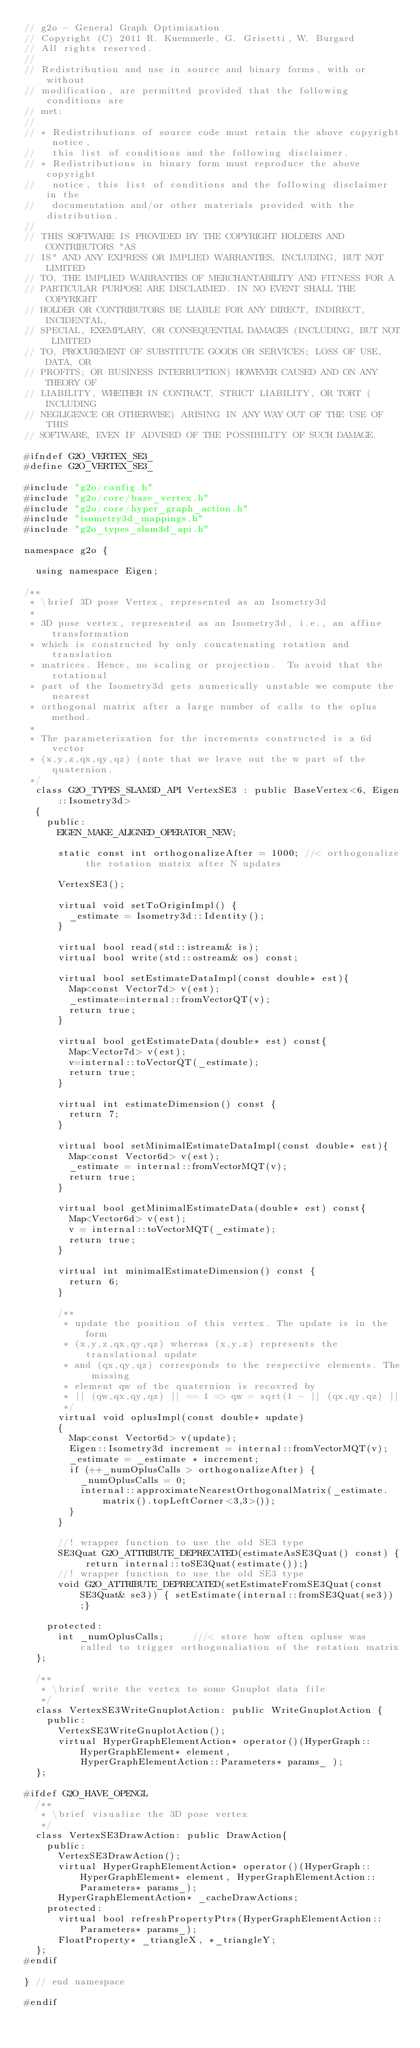Convert code to text. <code><loc_0><loc_0><loc_500><loc_500><_C_>// g2o - General Graph Optimization
// Copyright (C) 2011 R. Kuemmerle, G. Grisetti, W. Burgard
// All rights reserved.
//
// Redistribution and use in source and binary forms, with or without
// modification, are permitted provided that the following conditions are
// met:
//
// * Redistributions of source code must retain the above copyright notice,
//   this list of conditions and the following disclaimer.
// * Redistributions in binary form must reproduce the above copyright
//   notice, this list of conditions and the following disclaimer in the
//   documentation and/or other materials provided with the distribution.
//
// THIS SOFTWARE IS PROVIDED BY THE COPYRIGHT HOLDERS AND CONTRIBUTORS "AS
// IS" AND ANY EXPRESS OR IMPLIED WARRANTIES, INCLUDING, BUT NOT LIMITED
// TO, THE IMPLIED WARRANTIES OF MERCHANTABILITY AND FITNESS FOR A
// PARTICULAR PURPOSE ARE DISCLAIMED. IN NO EVENT SHALL THE COPYRIGHT
// HOLDER OR CONTRIBUTORS BE LIABLE FOR ANY DIRECT, INDIRECT, INCIDENTAL,
// SPECIAL, EXEMPLARY, OR CONSEQUENTIAL DAMAGES (INCLUDING, BUT NOT LIMITED
// TO, PROCUREMENT OF SUBSTITUTE GOODS OR SERVICES; LOSS OF USE, DATA, OR
// PROFITS; OR BUSINESS INTERRUPTION) HOWEVER CAUSED AND ON ANY THEORY OF
// LIABILITY, WHETHER IN CONTRACT, STRICT LIABILITY, OR TORT (INCLUDING
// NEGLIGENCE OR OTHERWISE) ARISING IN ANY WAY OUT OF THE USE OF THIS
// SOFTWARE, EVEN IF ADVISED OF THE POSSIBILITY OF SUCH DAMAGE.

#ifndef G2O_VERTEX_SE3_
#define G2O_VERTEX_SE3_

#include "g2o/config.h"
#include "g2o/core/base_vertex.h"
#include "g2o/core/hyper_graph_action.h"
#include "isometry3d_mappings.h"
#include "g2o_types_slam3d_api.h"

namespace g2o {

  using namespace Eigen;

/**
 * \brief 3D pose Vertex, represented as an Isometry3d
 *
 * 3D pose vertex, represented as an Isometry3d, i.e., an affine transformation
 * which is constructed by only concatenating rotation and translation
 * matrices. Hence, no scaling or projection.  To avoid that the rotational
 * part of the Isometry3d gets numerically unstable we compute the nearest
 * orthogonal matrix after a large number of calls to the oplus method.
 * 
 * The parameterization for the increments constructed is a 6d vector
 * (x,y,z,qx,qy,qz) (note that we leave out the w part of the quaternion.
 */
  class G2O_TYPES_SLAM3D_API VertexSE3 : public BaseVertex<6, Eigen::Isometry3d>
  {
    public:
      EIGEN_MAKE_ALIGNED_OPERATOR_NEW;

      static const int orthogonalizeAfter = 1000; //< orthogonalize the rotation matrix after N updates

      VertexSE3();

      virtual void setToOriginImpl() {
        _estimate = Isometry3d::Identity();
      }

      virtual bool read(std::istream& is);
      virtual bool write(std::ostream& os) const;

      virtual bool setEstimateDataImpl(const double* est){
        Map<const Vector7d> v(est);
        _estimate=internal::fromVectorQT(v);
        return true;
      }

      virtual bool getEstimateData(double* est) const{
        Map<Vector7d> v(est);
        v=internal::toVectorQT(_estimate);
        return true;
      }

      virtual int estimateDimension() const {
        return 7;
      }

      virtual bool setMinimalEstimateDataImpl(const double* est){
        Map<const Vector6d> v(est);
        _estimate = internal::fromVectorMQT(v);
        return true;
      }

      virtual bool getMinimalEstimateData(double* est) const{
        Map<Vector6d> v(est);
        v = internal::toVectorMQT(_estimate);
        return true;
      }

      virtual int minimalEstimateDimension() const {
        return 6;
      }

      /**
       * update the position of this vertex. The update is in the form
       * (x,y,z,qx,qy,qz) whereas (x,y,z) represents the translational update
       * and (qx,qy,qz) corresponds to the respective elements. The missing
       * element qw of the quaternion is recovred by
       * || (qw,qx,qy,qz) || == 1 => qw = sqrt(1 - || (qx,qy,qz) ||
       */
      virtual void oplusImpl(const double* update)
      {
        Map<const Vector6d> v(update);
        Eigen::Isometry3d increment = internal::fromVectorMQT(v);
        _estimate = _estimate * increment;
        if (++_numOplusCalls > orthogonalizeAfter) {
          _numOplusCalls = 0;
          internal::approximateNearestOrthogonalMatrix(_estimate.matrix().topLeftCorner<3,3>());
        }
      }

      //! wrapper function to use the old SE3 type
      SE3Quat G2O_ATTRIBUTE_DEPRECATED(estimateAsSE3Quat() const) { return internal::toSE3Quat(estimate());}
      //! wrapper function to use the old SE3 type
      void G2O_ATTRIBUTE_DEPRECATED(setEstimateFromSE3Quat(const SE3Quat& se3)) { setEstimate(internal::fromSE3Quat(se3));}

    protected:
      int _numOplusCalls;     ///< store how often opluse was called to trigger orthogonaliation of the rotation matrix
  };

  /**
   * \brief write the vertex to some Gnuplot data file
   */
  class VertexSE3WriteGnuplotAction: public WriteGnuplotAction {
    public:
      VertexSE3WriteGnuplotAction();
      virtual HyperGraphElementAction* operator()(HyperGraph::HyperGraphElement* element, 
          HyperGraphElementAction::Parameters* params_ );
  };

#ifdef G2O_HAVE_OPENGL
  /**
   * \brief visualize the 3D pose vertex
   */
  class VertexSE3DrawAction: public DrawAction{
    public:
      VertexSE3DrawAction();
      virtual HyperGraphElementAction* operator()(HyperGraph::HyperGraphElement* element, HyperGraphElementAction::Parameters* params_);
      HyperGraphElementAction* _cacheDrawActions;
    protected:
      virtual bool refreshPropertyPtrs(HyperGraphElementAction::Parameters* params_);
      FloatProperty* _triangleX, *_triangleY;
  };
#endif

} // end namespace

#endif
</code> 